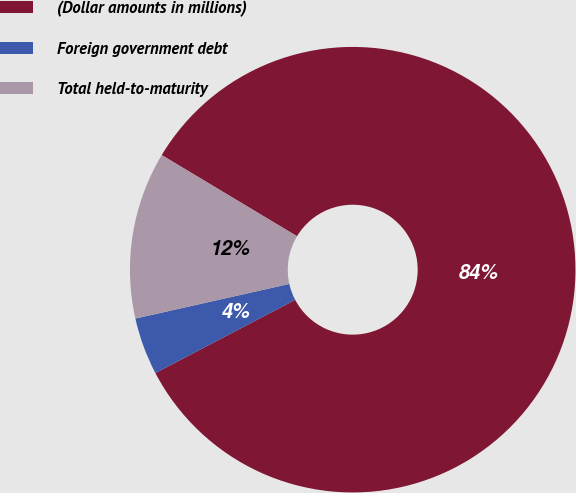<chart> <loc_0><loc_0><loc_500><loc_500><pie_chart><fcel>(Dollar amounts in millions)<fcel>Foreign government debt<fcel>Total held-to-maturity<nl><fcel>83.72%<fcel>4.16%<fcel>12.12%<nl></chart> 